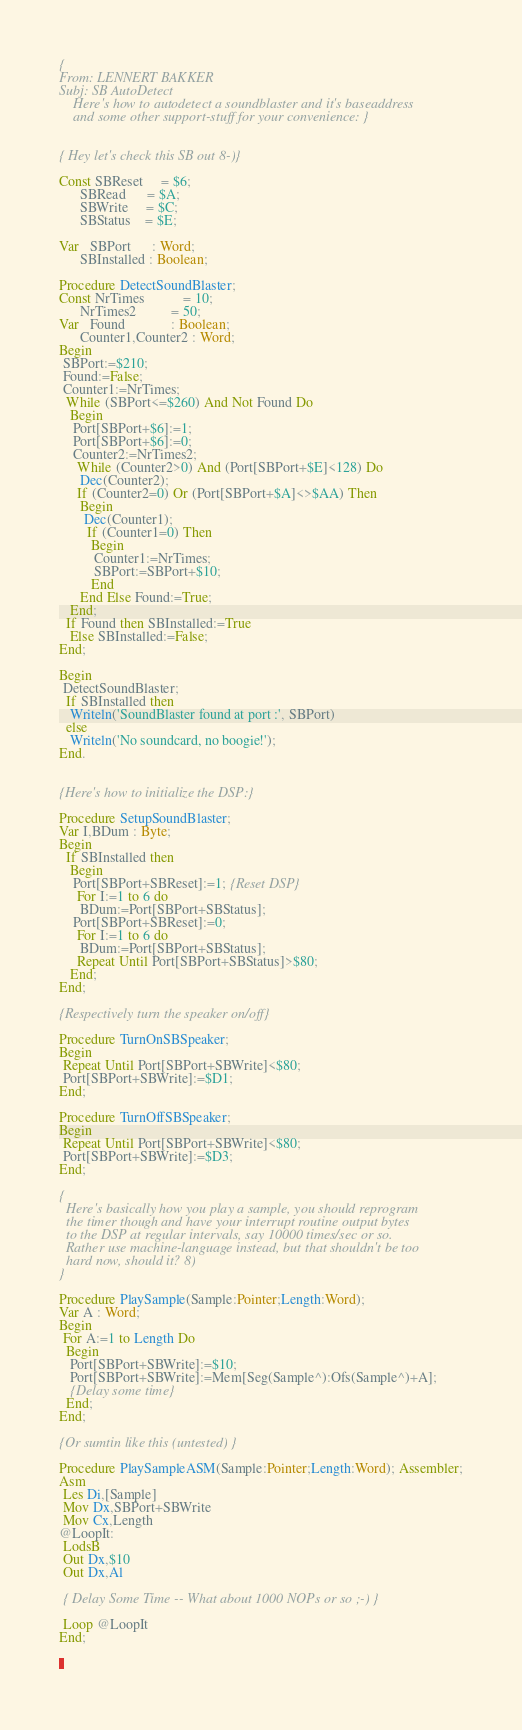<code> <loc_0><loc_0><loc_500><loc_500><_Pascal_>{
From: LENNERT BAKKER
Subj: SB AutoDetect
    Here's how to autodetect a soundblaster and it's baseaddress
    and some other support-stuff for your convenience: }


{ Hey let's check this SB out 8-)}

Const SBReset     = $6;
      SBRead      = $A;
      SBWrite     = $C;
      SBStatus    = $E;

Var   SBPort      : Word;
      SBInstalled : Boolean;

Procedure DetectSoundBlaster;
Const NrTimes           = 10;
      NrTimes2          = 50;
Var   Found             : Boolean;
      Counter1,Counter2 : Word;
Begin
 SBPort:=$210;
 Found:=False;
 Counter1:=NrTimes;
  While (SBPort<=$260) And Not Found Do
   Begin
    Port[SBPort+$6]:=1;
    Port[SBPort+$6]:=0;
    Counter2:=NrTimes2;
     While (Counter2>0) And (Port[SBPort+$E]<128) Do
      Dec(Counter2);
     If (Counter2=0) Or (Port[SBPort+$A]<>$AA) Then
      Begin
       Dec(Counter1);
        If (Counter1=0) Then
         Begin
          Counter1:=NrTimes;
          SBPort:=SBPort+$10;
         End
      End Else Found:=True;
   End;
  If Found then SBInstalled:=True
   Else SBInstalled:=False;
End;

Begin
 DetectSoundBlaster;
  If SBInstalled then
   Writeln('SoundBlaster found at port :', SBPort)
  else
   Writeln('No soundcard, no boogie!');
End.


{Here's how to initialize the DSP:}

Procedure SetupSoundBlaster;
Var I,BDum : Byte;
Begin
  If SBInstalled then
   Begin
    Port[SBPort+SBReset]:=1; {Reset DSP}
     For I:=1 to 6 do
      BDum:=Port[SBPort+SBStatus];
    Port[SBPort+SBReset]:=0;
     For I:=1 to 6 do
      BDum:=Port[SBPort+SBStatus];
     Repeat Until Port[SBPort+SBStatus]>$80;
   End;
End;

{Respectively turn the speaker on/off}

Procedure TurnOnSBSpeaker;
Begin
 Repeat Until Port[SBPort+SBWrite]<$80;
 Port[SBPort+SBWrite]:=$D1;
End;

Procedure TurnOffSBSpeaker;
Begin
 Repeat Until Port[SBPort+SBWrite]<$80;
 Port[SBPort+SBWrite]:=$D3;
End;

{
  Here's basically how you play a sample, you should reprogram
  the timer though and have your interrupt routine output bytes
  to the DSP at regular intervals, say 10000 times/sec or so.
  Rather use machine-language instead, but that shouldn't be too
  hard now, should it? 8)
}

Procedure PlaySample(Sample:Pointer;Length:Word);
Var A : Word;
Begin
 For A:=1 to Length Do
  Begin
   Port[SBPort+SBWrite]:=$10;
   Port[SBPort+SBWrite]:=Mem[Seg(Sample^):Ofs(Sample^)+A];
   {Delay some time}
  End;
End;

{Or sumtin like this (untested) }

Procedure PlaySampleASM(Sample:Pointer;Length:Word); Assembler;
Asm
 Les Di,[Sample]
 Mov Dx,SBPort+SBWrite
 Mov Cx,Length
@LoopIt:
 LodsB
 Out Dx,$10
 Out Dx,Al

 { Delay Some Time -- What about 1000 NOPs or so ;-) }

 Loop @LoopIt
End;

</code> 